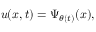<formula> <loc_0><loc_0><loc_500><loc_500>u ( x , t ) = \Psi _ { \theta ( t ) } ( x ) ,</formula> 